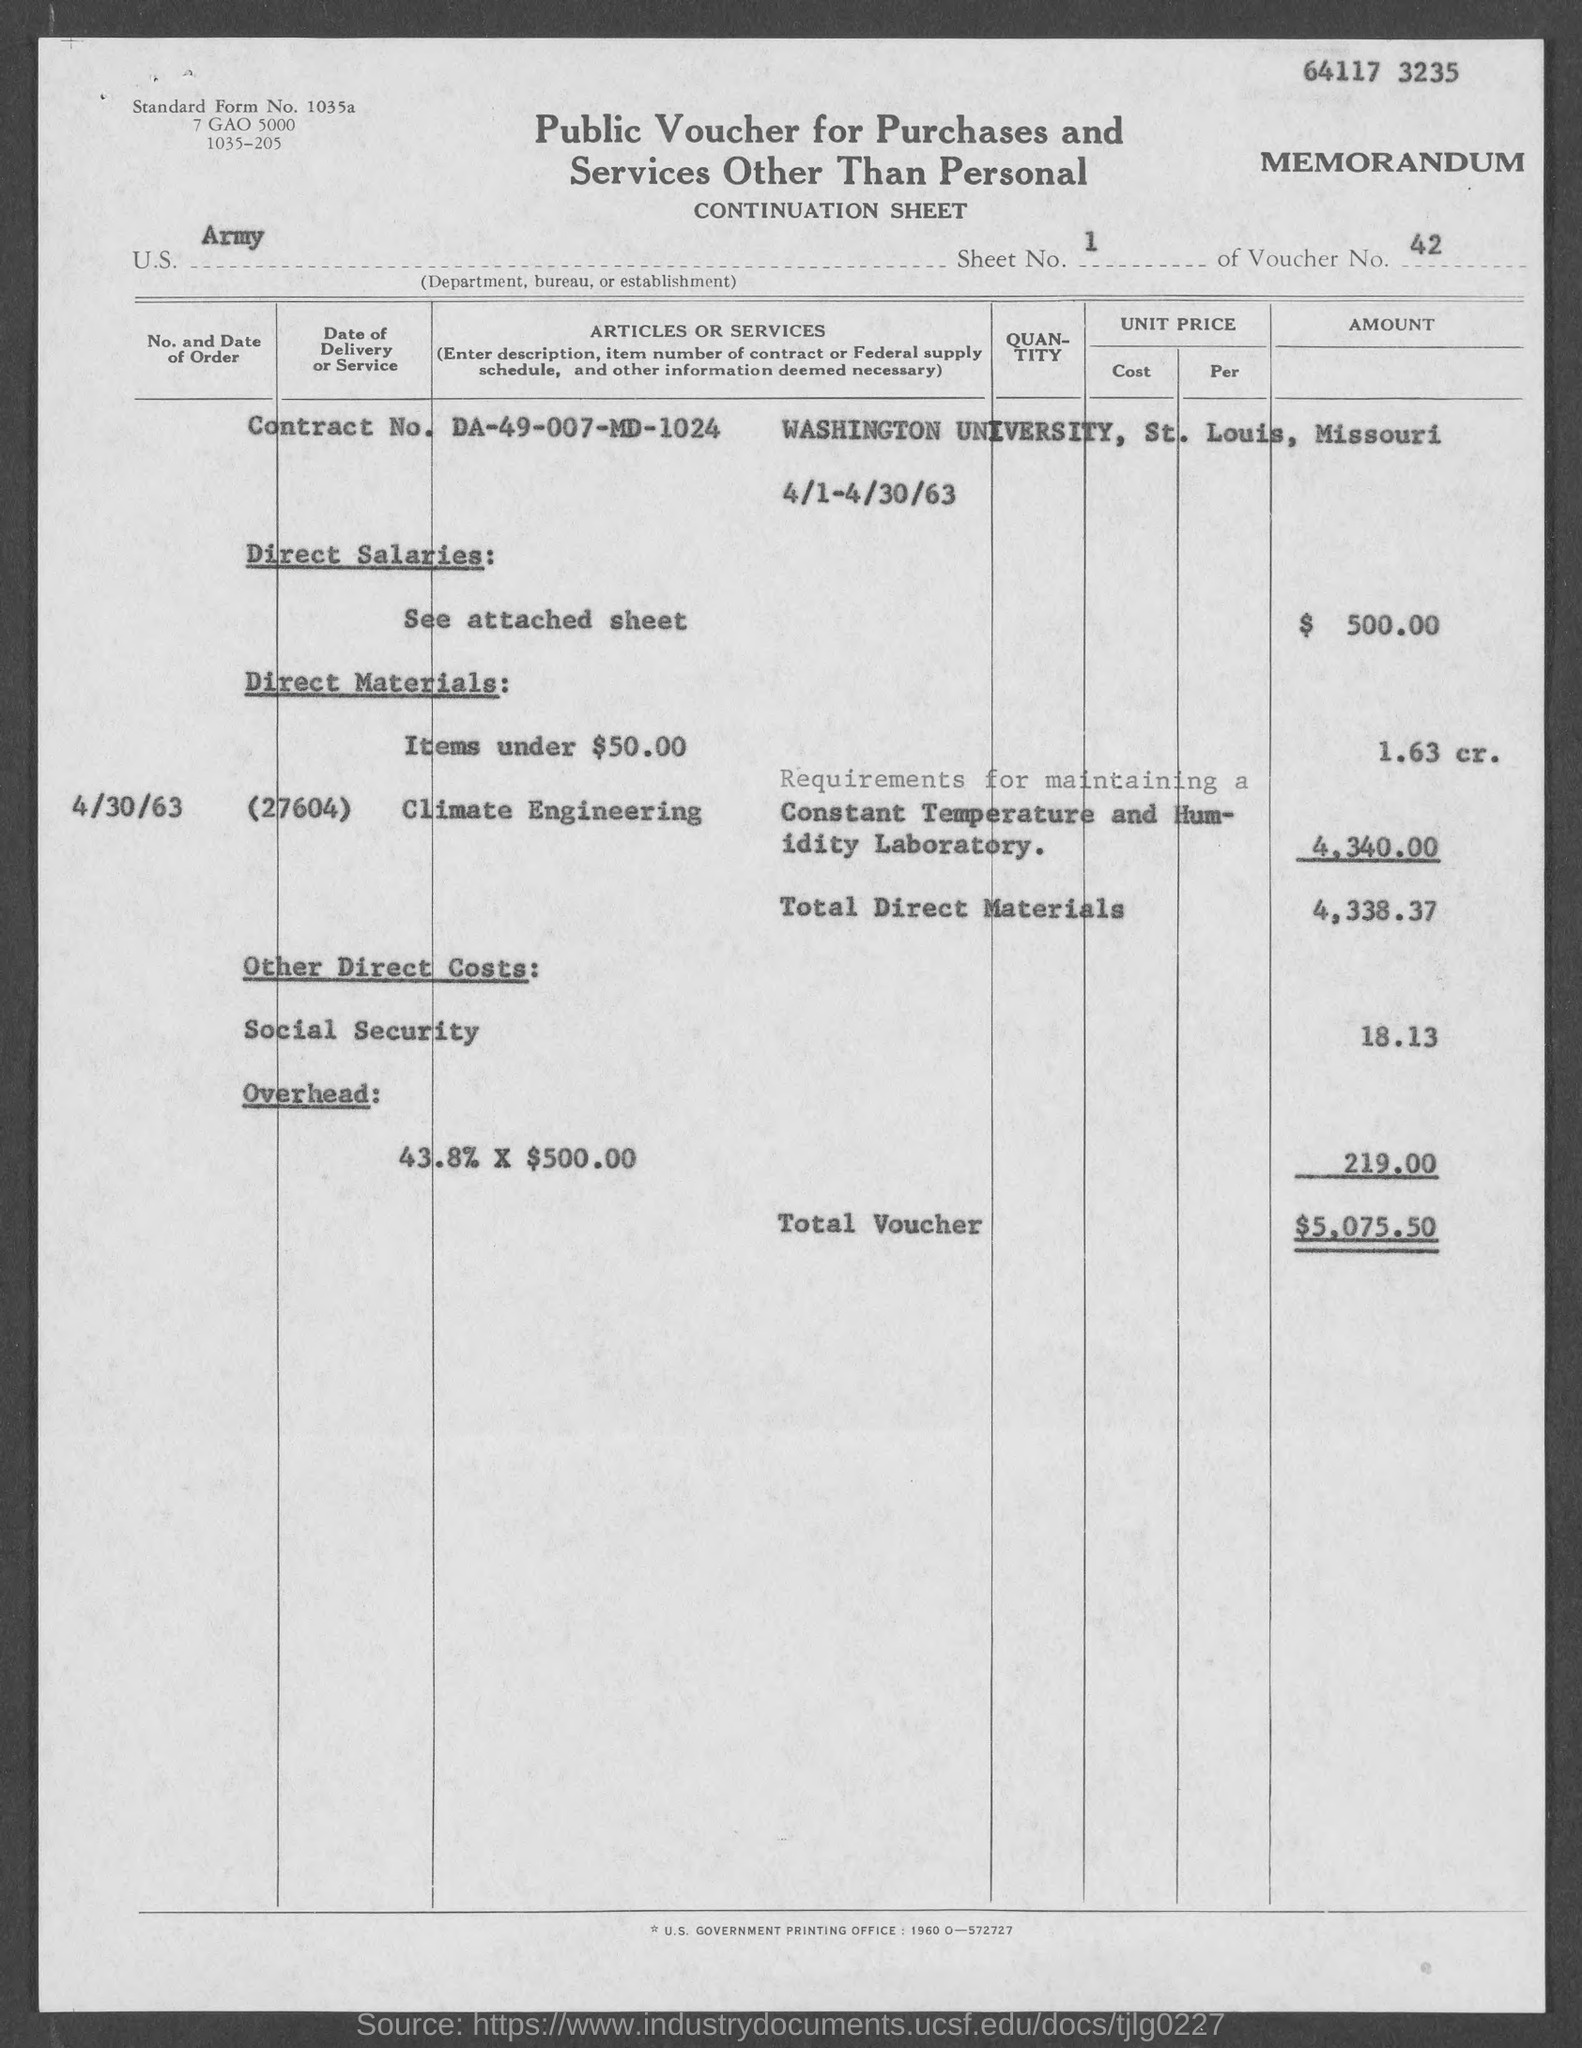What is the document title?
Keep it short and to the point. Public Voucher for Purchases and Services Other Than Personal. What is the voucher number?
Make the answer very short. 42. What is the Contract No.?
Give a very brief answer. DA-49-007-MD-1024. What is the amount of Direct Salaries?
Your answer should be compact. $ 500.00. What is the total voucher?
Your answer should be very brief. $5,075.50. 